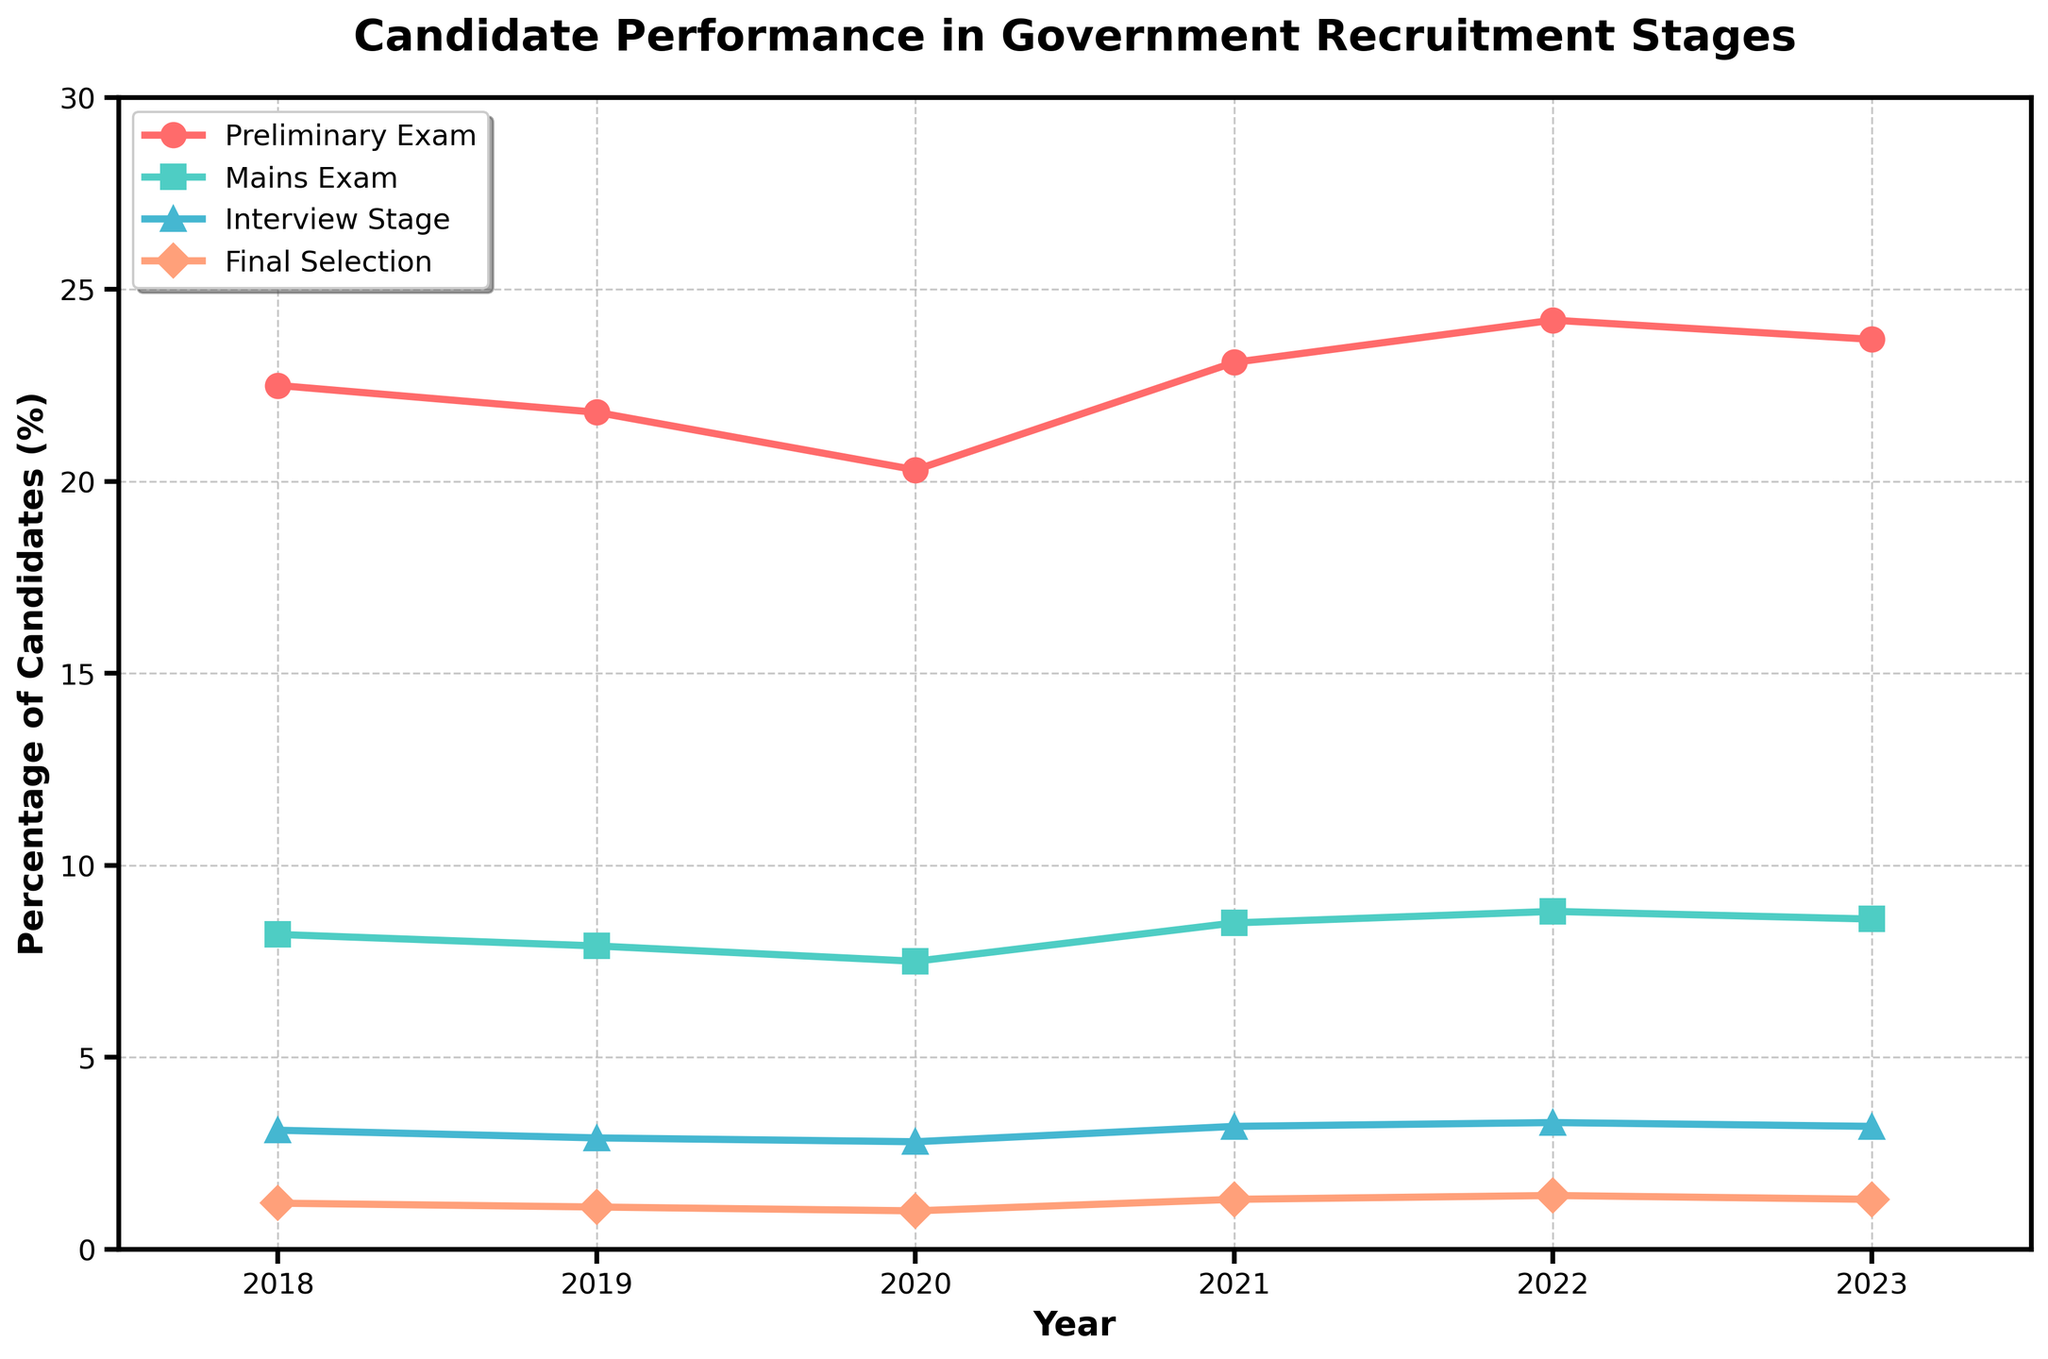What is the percentage of candidates who cleared the Preliminary Exam in 2021? Look at the line for the Preliminary Exam and find the value corresponding to the year 2021.
Answer: 23.1 Which year saw the highest percentage of candidates clearing the Interview Stage? Look for the peak value in the Interview Stage line and find the corresponding year.
Answer: 2022 How did the percentage of candidates clearing the Mains Exam change from 2020 to 2023? Note the values for Mains Exam in 2020 and 2023, then calculate the difference.
Answer: Increased by 1.1% Between which two years did the Final Selection percentage remain unchanged? Observe the Final Selection line and identify two consecutive years with the same percentage value.
Answer: 2021 and 2023 Which stage had the most variation in percentage over the years? Compare the range of values (difference between max and min) for each stage's line on the chart.
Answer: Preliminary Exam Calculate the average percentage of candidates clearing the Final Selection stage from 2018 to 2023. Sum the percentages for the Final Selection stage for all years and divide by the number of years: (1.2 + 1.1 + 1.0 + 1.3 + 1.4 + 1.3) / 6.
Answer: 1.22 By how much did the percentage of candidates clearing the Preliminary Exam increase from 2020 to 2022? Subtract the percentage in 2020 from the percentage in 2022 for the Preliminary Exam.
Answer: 3.9% Which stage consistently had the lowest percentage of candidates clearing it every year? Look at each stage's line on the chart and identify the one that has the lowest values throughout.
Answer: Final Selection Compare the percentage of candidates clearing the Mains Exam in 2018 and 2023. Note the values for Mains Exam in both years and discuss the difference.
Answer: Decreased by 0.4% What is the total percentage of candidates who cleared the Preliminary Exam and Mains Exam in 2020? Sum the percentages of candidates clearing the Preliminary Exam and Mains Exam in 2020: 20.3 + 7.5.
Answer: 27.8 